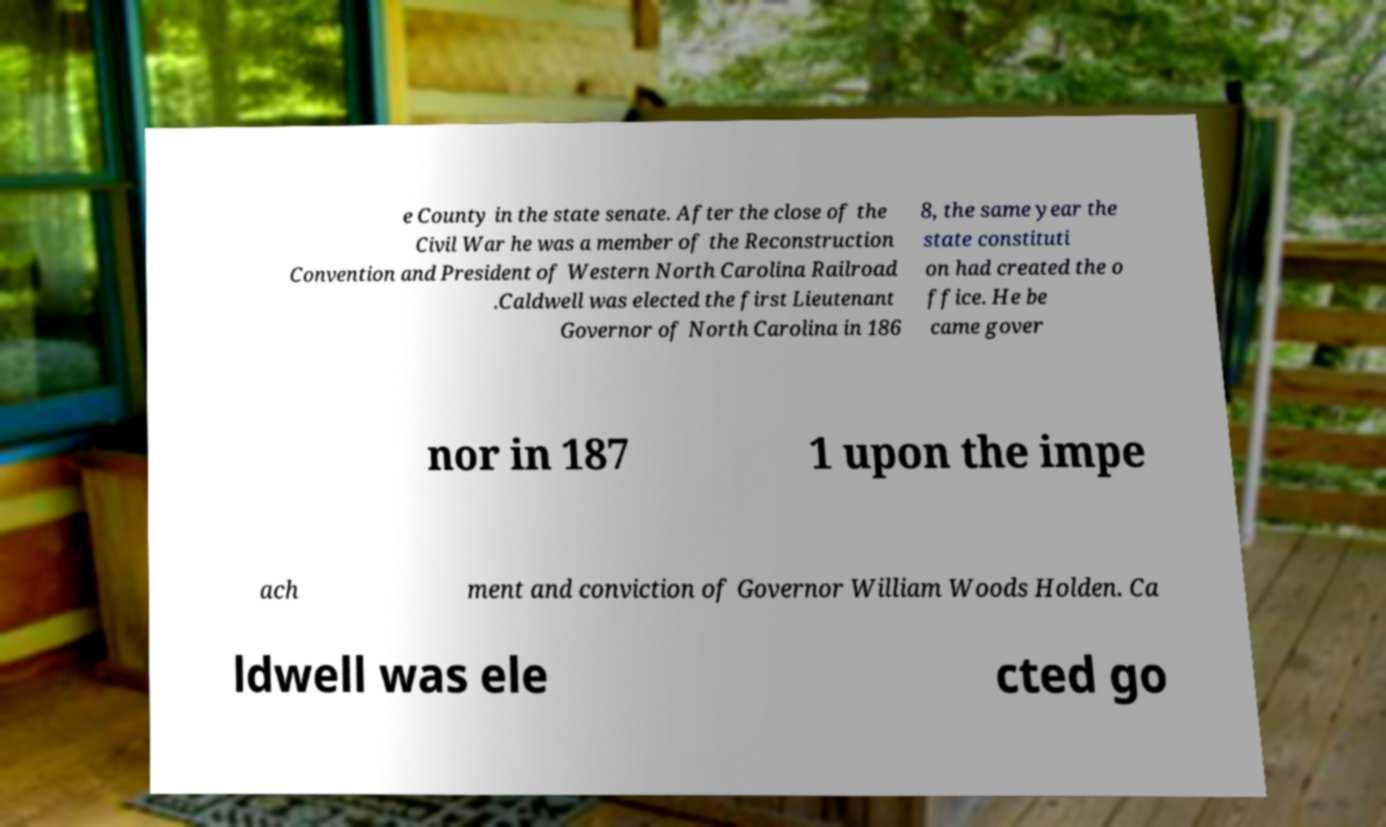Please identify and transcribe the text found in this image. e County in the state senate. After the close of the Civil War he was a member of the Reconstruction Convention and President of Western North Carolina Railroad .Caldwell was elected the first Lieutenant Governor of North Carolina in 186 8, the same year the state constituti on had created the o ffice. He be came gover nor in 187 1 upon the impe ach ment and conviction of Governor William Woods Holden. Ca ldwell was ele cted go 